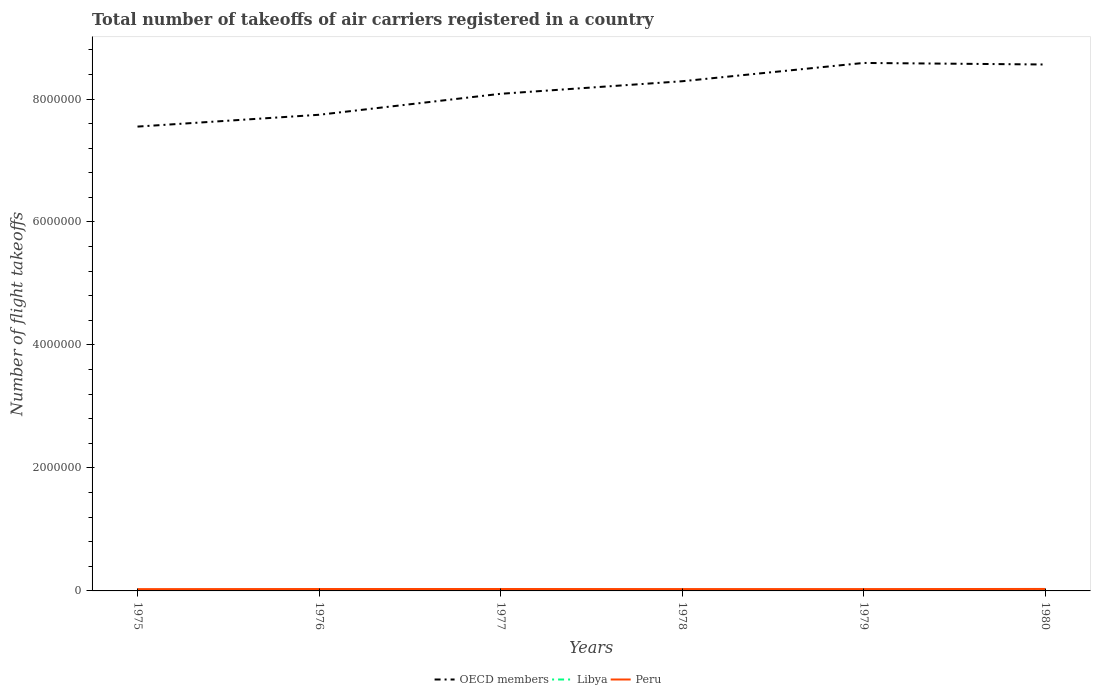How many different coloured lines are there?
Give a very brief answer. 3. Does the line corresponding to OECD members intersect with the line corresponding to Peru?
Provide a succinct answer. No. Across all years, what is the maximum total number of flight takeoffs in OECD members?
Your response must be concise. 7.55e+06. In which year was the total number of flight takeoffs in OECD members maximum?
Keep it short and to the point. 1975. What is the total total number of flight takeoffs in OECD members in the graph?
Offer a very short reply. -5.02e+05. What is the difference between the highest and the second highest total number of flight takeoffs in Libya?
Your answer should be compact. 2700. What is the difference between the highest and the lowest total number of flight takeoffs in Peru?
Make the answer very short. 3. Is the total number of flight takeoffs in OECD members strictly greater than the total number of flight takeoffs in Libya over the years?
Your answer should be very brief. No. How many lines are there?
Ensure brevity in your answer.  3. Does the graph contain any zero values?
Your answer should be very brief. No. Where does the legend appear in the graph?
Give a very brief answer. Bottom center. How many legend labels are there?
Offer a very short reply. 3. How are the legend labels stacked?
Keep it short and to the point. Horizontal. What is the title of the graph?
Keep it short and to the point. Total number of takeoffs of air carriers registered in a country. Does "Poland" appear as one of the legend labels in the graph?
Give a very brief answer. No. What is the label or title of the X-axis?
Your answer should be very brief. Years. What is the label or title of the Y-axis?
Give a very brief answer. Number of flight takeoffs. What is the Number of flight takeoffs in OECD members in 1975?
Give a very brief answer. 7.55e+06. What is the Number of flight takeoffs of Libya in 1975?
Give a very brief answer. 9500. What is the Number of flight takeoffs in Peru in 1975?
Your response must be concise. 2.93e+04. What is the Number of flight takeoffs in OECD members in 1976?
Make the answer very short. 7.74e+06. What is the Number of flight takeoffs of Libya in 1976?
Offer a very short reply. 9800. What is the Number of flight takeoffs in Peru in 1976?
Your answer should be compact. 3.09e+04. What is the Number of flight takeoffs of OECD members in 1977?
Offer a terse response. 8.08e+06. What is the Number of flight takeoffs of Libya in 1977?
Give a very brief answer. 1.11e+04. What is the Number of flight takeoffs of Peru in 1977?
Make the answer very short. 3.12e+04. What is the Number of flight takeoffs of OECD members in 1978?
Make the answer very short. 8.29e+06. What is the Number of flight takeoffs in Libya in 1978?
Give a very brief answer. 1.11e+04. What is the Number of flight takeoffs of Peru in 1978?
Keep it short and to the point. 3.03e+04. What is the Number of flight takeoffs of OECD members in 1979?
Ensure brevity in your answer.  8.59e+06. What is the Number of flight takeoffs in Libya in 1979?
Provide a succinct answer. 1.16e+04. What is the Number of flight takeoffs in Peru in 1979?
Make the answer very short. 2.99e+04. What is the Number of flight takeoffs of OECD members in 1980?
Offer a very short reply. 8.56e+06. What is the Number of flight takeoffs in Libya in 1980?
Ensure brevity in your answer.  1.22e+04. What is the Number of flight takeoffs of Peru in 1980?
Your answer should be very brief. 3.21e+04. Across all years, what is the maximum Number of flight takeoffs in OECD members?
Keep it short and to the point. 8.59e+06. Across all years, what is the maximum Number of flight takeoffs of Libya?
Provide a short and direct response. 1.22e+04. Across all years, what is the maximum Number of flight takeoffs in Peru?
Offer a terse response. 3.21e+04. Across all years, what is the minimum Number of flight takeoffs of OECD members?
Make the answer very short. 7.55e+06. Across all years, what is the minimum Number of flight takeoffs in Libya?
Give a very brief answer. 9500. Across all years, what is the minimum Number of flight takeoffs of Peru?
Offer a terse response. 2.93e+04. What is the total Number of flight takeoffs of OECD members in the graph?
Your response must be concise. 4.88e+07. What is the total Number of flight takeoffs in Libya in the graph?
Offer a terse response. 6.53e+04. What is the total Number of flight takeoffs in Peru in the graph?
Keep it short and to the point. 1.84e+05. What is the difference between the Number of flight takeoffs of OECD members in 1975 and that in 1976?
Offer a very short reply. -1.92e+05. What is the difference between the Number of flight takeoffs in Libya in 1975 and that in 1976?
Your answer should be very brief. -300. What is the difference between the Number of flight takeoffs in Peru in 1975 and that in 1976?
Provide a succinct answer. -1600. What is the difference between the Number of flight takeoffs of OECD members in 1975 and that in 1977?
Your response must be concise. -5.33e+05. What is the difference between the Number of flight takeoffs of Libya in 1975 and that in 1977?
Your response must be concise. -1600. What is the difference between the Number of flight takeoffs in Peru in 1975 and that in 1977?
Give a very brief answer. -1900. What is the difference between the Number of flight takeoffs in OECD members in 1975 and that in 1978?
Ensure brevity in your answer.  -7.38e+05. What is the difference between the Number of flight takeoffs in Libya in 1975 and that in 1978?
Your answer should be compact. -1600. What is the difference between the Number of flight takeoffs of Peru in 1975 and that in 1978?
Offer a terse response. -1000. What is the difference between the Number of flight takeoffs of OECD members in 1975 and that in 1979?
Make the answer very short. -1.04e+06. What is the difference between the Number of flight takeoffs in Libya in 1975 and that in 1979?
Ensure brevity in your answer.  -2100. What is the difference between the Number of flight takeoffs of Peru in 1975 and that in 1979?
Give a very brief answer. -600. What is the difference between the Number of flight takeoffs of OECD members in 1975 and that in 1980?
Your answer should be very brief. -1.01e+06. What is the difference between the Number of flight takeoffs of Libya in 1975 and that in 1980?
Make the answer very short. -2700. What is the difference between the Number of flight takeoffs of Peru in 1975 and that in 1980?
Provide a succinct answer. -2800. What is the difference between the Number of flight takeoffs of OECD members in 1976 and that in 1977?
Make the answer very short. -3.41e+05. What is the difference between the Number of flight takeoffs of Libya in 1976 and that in 1977?
Ensure brevity in your answer.  -1300. What is the difference between the Number of flight takeoffs in Peru in 1976 and that in 1977?
Give a very brief answer. -300. What is the difference between the Number of flight takeoffs in OECD members in 1976 and that in 1978?
Your response must be concise. -5.45e+05. What is the difference between the Number of flight takeoffs in Libya in 1976 and that in 1978?
Provide a succinct answer. -1300. What is the difference between the Number of flight takeoffs in Peru in 1976 and that in 1978?
Keep it short and to the point. 600. What is the difference between the Number of flight takeoffs in OECD members in 1976 and that in 1979?
Your answer should be compact. -8.43e+05. What is the difference between the Number of flight takeoffs of Libya in 1976 and that in 1979?
Offer a terse response. -1800. What is the difference between the Number of flight takeoffs in OECD members in 1976 and that in 1980?
Keep it short and to the point. -8.18e+05. What is the difference between the Number of flight takeoffs of Libya in 1976 and that in 1980?
Provide a short and direct response. -2400. What is the difference between the Number of flight takeoffs of Peru in 1976 and that in 1980?
Offer a very short reply. -1200. What is the difference between the Number of flight takeoffs in OECD members in 1977 and that in 1978?
Offer a very short reply. -2.04e+05. What is the difference between the Number of flight takeoffs in Libya in 1977 and that in 1978?
Give a very brief answer. 0. What is the difference between the Number of flight takeoffs of Peru in 1977 and that in 1978?
Offer a terse response. 900. What is the difference between the Number of flight takeoffs in OECD members in 1977 and that in 1979?
Offer a very short reply. -5.02e+05. What is the difference between the Number of flight takeoffs of Libya in 1977 and that in 1979?
Your answer should be compact. -500. What is the difference between the Number of flight takeoffs of Peru in 1977 and that in 1979?
Offer a very short reply. 1300. What is the difference between the Number of flight takeoffs of OECD members in 1977 and that in 1980?
Your answer should be compact. -4.77e+05. What is the difference between the Number of flight takeoffs in Libya in 1977 and that in 1980?
Your answer should be compact. -1100. What is the difference between the Number of flight takeoffs of Peru in 1977 and that in 1980?
Keep it short and to the point. -900. What is the difference between the Number of flight takeoffs of OECD members in 1978 and that in 1979?
Keep it short and to the point. -2.98e+05. What is the difference between the Number of flight takeoffs of Libya in 1978 and that in 1979?
Make the answer very short. -500. What is the difference between the Number of flight takeoffs of Peru in 1978 and that in 1979?
Your answer should be compact. 400. What is the difference between the Number of flight takeoffs in OECD members in 1978 and that in 1980?
Your answer should be compact. -2.72e+05. What is the difference between the Number of flight takeoffs of Libya in 1978 and that in 1980?
Give a very brief answer. -1100. What is the difference between the Number of flight takeoffs in Peru in 1978 and that in 1980?
Provide a short and direct response. -1800. What is the difference between the Number of flight takeoffs of OECD members in 1979 and that in 1980?
Offer a terse response. 2.53e+04. What is the difference between the Number of flight takeoffs of Libya in 1979 and that in 1980?
Give a very brief answer. -600. What is the difference between the Number of flight takeoffs in Peru in 1979 and that in 1980?
Make the answer very short. -2200. What is the difference between the Number of flight takeoffs in OECD members in 1975 and the Number of flight takeoffs in Libya in 1976?
Provide a succinct answer. 7.54e+06. What is the difference between the Number of flight takeoffs of OECD members in 1975 and the Number of flight takeoffs of Peru in 1976?
Your answer should be very brief. 7.52e+06. What is the difference between the Number of flight takeoffs of Libya in 1975 and the Number of flight takeoffs of Peru in 1976?
Your response must be concise. -2.14e+04. What is the difference between the Number of flight takeoffs in OECD members in 1975 and the Number of flight takeoffs in Libya in 1977?
Keep it short and to the point. 7.54e+06. What is the difference between the Number of flight takeoffs in OECD members in 1975 and the Number of flight takeoffs in Peru in 1977?
Ensure brevity in your answer.  7.52e+06. What is the difference between the Number of flight takeoffs in Libya in 1975 and the Number of flight takeoffs in Peru in 1977?
Your response must be concise. -2.17e+04. What is the difference between the Number of flight takeoffs of OECD members in 1975 and the Number of flight takeoffs of Libya in 1978?
Make the answer very short. 7.54e+06. What is the difference between the Number of flight takeoffs in OECD members in 1975 and the Number of flight takeoffs in Peru in 1978?
Offer a terse response. 7.52e+06. What is the difference between the Number of flight takeoffs of Libya in 1975 and the Number of flight takeoffs of Peru in 1978?
Ensure brevity in your answer.  -2.08e+04. What is the difference between the Number of flight takeoffs in OECD members in 1975 and the Number of flight takeoffs in Libya in 1979?
Keep it short and to the point. 7.54e+06. What is the difference between the Number of flight takeoffs in OECD members in 1975 and the Number of flight takeoffs in Peru in 1979?
Provide a succinct answer. 7.52e+06. What is the difference between the Number of flight takeoffs in Libya in 1975 and the Number of flight takeoffs in Peru in 1979?
Ensure brevity in your answer.  -2.04e+04. What is the difference between the Number of flight takeoffs of OECD members in 1975 and the Number of flight takeoffs of Libya in 1980?
Provide a short and direct response. 7.54e+06. What is the difference between the Number of flight takeoffs of OECD members in 1975 and the Number of flight takeoffs of Peru in 1980?
Your response must be concise. 7.52e+06. What is the difference between the Number of flight takeoffs of Libya in 1975 and the Number of flight takeoffs of Peru in 1980?
Provide a short and direct response. -2.26e+04. What is the difference between the Number of flight takeoffs in OECD members in 1976 and the Number of flight takeoffs in Libya in 1977?
Provide a succinct answer. 7.73e+06. What is the difference between the Number of flight takeoffs in OECD members in 1976 and the Number of flight takeoffs in Peru in 1977?
Ensure brevity in your answer.  7.71e+06. What is the difference between the Number of flight takeoffs of Libya in 1976 and the Number of flight takeoffs of Peru in 1977?
Offer a terse response. -2.14e+04. What is the difference between the Number of flight takeoffs in OECD members in 1976 and the Number of flight takeoffs in Libya in 1978?
Give a very brief answer. 7.73e+06. What is the difference between the Number of flight takeoffs of OECD members in 1976 and the Number of flight takeoffs of Peru in 1978?
Your answer should be very brief. 7.71e+06. What is the difference between the Number of flight takeoffs in Libya in 1976 and the Number of flight takeoffs in Peru in 1978?
Provide a short and direct response. -2.05e+04. What is the difference between the Number of flight takeoffs of OECD members in 1976 and the Number of flight takeoffs of Libya in 1979?
Offer a very short reply. 7.73e+06. What is the difference between the Number of flight takeoffs in OECD members in 1976 and the Number of flight takeoffs in Peru in 1979?
Offer a terse response. 7.71e+06. What is the difference between the Number of flight takeoffs of Libya in 1976 and the Number of flight takeoffs of Peru in 1979?
Your response must be concise. -2.01e+04. What is the difference between the Number of flight takeoffs in OECD members in 1976 and the Number of flight takeoffs in Libya in 1980?
Ensure brevity in your answer.  7.73e+06. What is the difference between the Number of flight takeoffs in OECD members in 1976 and the Number of flight takeoffs in Peru in 1980?
Give a very brief answer. 7.71e+06. What is the difference between the Number of flight takeoffs in Libya in 1976 and the Number of flight takeoffs in Peru in 1980?
Ensure brevity in your answer.  -2.23e+04. What is the difference between the Number of flight takeoffs of OECD members in 1977 and the Number of flight takeoffs of Libya in 1978?
Offer a terse response. 8.07e+06. What is the difference between the Number of flight takeoffs of OECD members in 1977 and the Number of flight takeoffs of Peru in 1978?
Make the answer very short. 8.05e+06. What is the difference between the Number of flight takeoffs in Libya in 1977 and the Number of flight takeoffs in Peru in 1978?
Ensure brevity in your answer.  -1.92e+04. What is the difference between the Number of flight takeoffs of OECD members in 1977 and the Number of flight takeoffs of Libya in 1979?
Provide a succinct answer. 8.07e+06. What is the difference between the Number of flight takeoffs of OECD members in 1977 and the Number of flight takeoffs of Peru in 1979?
Give a very brief answer. 8.05e+06. What is the difference between the Number of flight takeoffs of Libya in 1977 and the Number of flight takeoffs of Peru in 1979?
Give a very brief answer. -1.88e+04. What is the difference between the Number of flight takeoffs in OECD members in 1977 and the Number of flight takeoffs in Libya in 1980?
Your answer should be compact. 8.07e+06. What is the difference between the Number of flight takeoffs of OECD members in 1977 and the Number of flight takeoffs of Peru in 1980?
Your response must be concise. 8.05e+06. What is the difference between the Number of flight takeoffs of Libya in 1977 and the Number of flight takeoffs of Peru in 1980?
Provide a succinct answer. -2.10e+04. What is the difference between the Number of flight takeoffs of OECD members in 1978 and the Number of flight takeoffs of Libya in 1979?
Provide a succinct answer. 8.28e+06. What is the difference between the Number of flight takeoffs in OECD members in 1978 and the Number of flight takeoffs in Peru in 1979?
Ensure brevity in your answer.  8.26e+06. What is the difference between the Number of flight takeoffs of Libya in 1978 and the Number of flight takeoffs of Peru in 1979?
Give a very brief answer. -1.88e+04. What is the difference between the Number of flight takeoffs in OECD members in 1978 and the Number of flight takeoffs in Libya in 1980?
Offer a very short reply. 8.28e+06. What is the difference between the Number of flight takeoffs in OECD members in 1978 and the Number of flight takeoffs in Peru in 1980?
Your answer should be very brief. 8.26e+06. What is the difference between the Number of flight takeoffs in Libya in 1978 and the Number of flight takeoffs in Peru in 1980?
Your response must be concise. -2.10e+04. What is the difference between the Number of flight takeoffs of OECD members in 1979 and the Number of flight takeoffs of Libya in 1980?
Make the answer very short. 8.57e+06. What is the difference between the Number of flight takeoffs of OECD members in 1979 and the Number of flight takeoffs of Peru in 1980?
Give a very brief answer. 8.55e+06. What is the difference between the Number of flight takeoffs of Libya in 1979 and the Number of flight takeoffs of Peru in 1980?
Offer a very short reply. -2.05e+04. What is the average Number of flight takeoffs of OECD members per year?
Your answer should be compact. 8.14e+06. What is the average Number of flight takeoffs of Libya per year?
Keep it short and to the point. 1.09e+04. What is the average Number of flight takeoffs in Peru per year?
Your answer should be very brief. 3.06e+04. In the year 1975, what is the difference between the Number of flight takeoffs of OECD members and Number of flight takeoffs of Libya?
Your response must be concise. 7.54e+06. In the year 1975, what is the difference between the Number of flight takeoffs of OECD members and Number of flight takeoffs of Peru?
Your response must be concise. 7.52e+06. In the year 1975, what is the difference between the Number of flight takeoffs in Libya and Number of flight takeoffs in Peru?
Ensure brevity in your answer.  -1.98e+04. In the year 1976, what is the difference between the Number of flight takeoffs of OECD members and Number of flight takeoffs of Libya?
Keep it short and to the point. 7.73e+06. In the year 1976, what is the difference between the Number of flight takeoffs of OECD members and Number of flight takeoffs of Peru?
Ensure brevity in your answer.  7.71e+06. In the year 1976, what is the difference between the Number of flight takeoffs of Libya and Number of flight takeoffs of Peru?
Offer a very short reply. -2.11e+04. In the year 1977, what is the difference between the Number of flight takeoffs in OECD members and Number of flight takeoffs in Libya?
Provide a succinct answer. 8.07e+06. In the year 1977, what is the difference between the Number of flight takeoffs in OECD members and Number of flight takeoffs in Peru?
Your response must be concise. 8.05e+06. In the year 1977, what is the difference between the Number of flight takeoffs of Libya and Number of flight takeoffs of Peru?
Provide a short and direct response. -2.01e+04. In the year 1978, what is the difference between the Number of flight takeoffs of OECD members and Number of flight takeoffs of Libya?
Provide a succinct answer. 8.28e+06. In the year 1978, what is the difference between the Number of flight takeoffs of OECD members and Number of flight takeoffs of Peru?
Give a very brief answer. 8.26e+06. In the year 1978, what is the difference between the Number of flight takeoffs of Libya and Number of flight takeoffs of Peru?
Keep it short and to the point. -1.92e+04. In the year 1979, what is the difference between the Number of flight takeoffs in OECD members and Number of flight takeoffs in Libya?
Your answer should be compact. 8.58e+06. In the year 1979, what is the difference between the Number of flight takeoffs in OECD members and Number of flight takeoffs in Peru?
Offer a terse response. 8.56e+06. In the year 1979, what is the difference between the Number of flight takeoffs of Libya and Number of flight takeoffs of Peru?
Provide a succinct answer. -1.83e+04. In the year 1980, what is the difference between the Number of flight takeoffs of OECD members and Number of flight takeoffs of Libya?
Make the answer very short. 8.55e+06. In the year 1980, what is the difference between the Number of flight takeoffs of OECD members and Number of flight takeoffs of Peru?
Your answer should be very brief. 8.53e+06. In the year 1980, what is the difference between the Number of flight takeoffs in Libya and Number of flight takeoffs in Peru?
Offer a terse response. -1.99e+04. What is the ratio of the Number of flight takeoffs of OECD members in 1975 to that in 1976?
Keep it short and to the point. 0.98. What is the ratio of the Number of flight takeoffs in Libya in 1975 to that in 1976?
Keep it short and to the point. 0.97. What is the ratio of the Number of flight takeoffs of Peru in 1975 to that in 1976?
Your answer should be very brief. 0.95. What is the ratio of the Number of flight takeoffs of OECD members in 1975 to that in 1977?
Provide a short and direct response. 0.93. What is the ratio of the Number of flight takeoffs of Libya in 1975 to that in 1977?
Offer a very short reply. 0.86. What is the ratio of the Number of flight takeoffs in Peru in 1975 to that in 1977?
Make the answer very short. 0.94. What is the ratio of the Number of flight takeoffs of OECD members in 1975 to that in 1978?
Your answer should be compact. 0.91. What is the ratio of the Number of flight takeoffs in Libya in 1975 to that in 1978?
Offer a very short reply. 0.86. What is the ratio of the Number of flight takeoffs in OECD members in 1975 to that in 1979?
Offer a very short reply. 0.88. What is the ratio of the Number of flight takeoffs in Libya in 1975 to that in 1979?
Your response must be concise. 0.82. What is the ratio of the Number of flight takeoffs of Peru in 1975 to that in 1979?
Keep it short and to the point. 0.98. What is the ratio of the Number of flight takeoffs of OECD members in 1975 to that in 1980?
Ensure brevity in your answer.  0.88. What is the ratio of the Number of flight takeoffs of Libya in 1975 to that in 1980?
Your answer should be very brief. 0.78. What is the ratio of the Number of flight takeoffs in Peru in 1975 to that in 1980?
Make the answer very short. 0.91. What is the ratio of the Number of flight takeoffs in OECD members in 1976 to that in 1977?
Your response must be concise. 0.96. What is the ratio of the Number of flight takeoffs in Libya in 1976 to that in 1977?
Your answer should be very brief. 0.88. What is the ratio of the Number of flight takeoffs in OECD members in 1976 to that in 1978?
Make the answer very short. 0.93. What is the ratio of the Number of flight takeoffs in Libya in 1976 to that in 1978?
Your response must be concise. 0.88. What is the ratio of the Number of flight takeoffs of Peru in 1976 to that in 1978?
Your answer should be compact. 1.02. What is the ratio of the Number of flight takeoffs of OECD members in 1976 to that in 1979?
Provide a succinct answer. 0.9. What is the ratio of the Number of flight takeoffs of Libya in 1976 to that in 1979?
Offer a terse response. 0.84. What is the ratio of the Number of flight takeoffs of Peru in 1976 to that in 1979?
Make the answer very short. 1.03. What is the ratio of the Number of flight takeoffs of OECD members in 1976 to that in 1980?
Keep it short and to the point. 0.9. What is the ratio of the Number of flight takeoffs of Libya in 1976 to that in 1980?
Provide a succinct answer. 0.8. What is the ratio of the Number of flight takeoffs in Peru in 1976 to that in 1980?
Offer a terse response. 0.96. What is the ratio of the Number of flight takeoffs in OECD members in 1977 to that in 1978?
Your answer should be very brief. 0.98. What is the ratio of the Number of flight takeoffs in Peru in 1977 to that in 1978?
Your answer should be very brief. 1.03. What is the ratio of the Number of flight takeoffs of OECD members in 1977 to that in 1979?
Make the answer very short. 0.94. What is the ratio of the Number of flight takeoffs of Libya in 1977 to that in 1979?
Offer a very short reply. 0.96. What is the ratio of the Number of flight takeoffs of Peru in 1977 to that in 1979?
Provide a succinct answer. 1.04. What is the ratio of the Number of flight takeoffs in OECD members in 1977 to that in 1980?
Offer a very short reply. 0.94. What is the ratio of the Number of flight takeoffs in Libya in 1977 to that in 1980?
Make the answer very short. 0.91. What is the ratio of the Number of flight takeoffs in Peru in 1977 to that in 1980?
Give a very brief answer. 0.97. What is the ratio of the Number of flight takeoffs in OECD members in 1978 to that in 1979?
Give a very brief answer. 0.97. What is the ratio of the Number of flight takeoffs of Libya in 1978 to that in 1979?
Your response must be concise. 0.96. What is the ratio of the Number of flight takeoffs of Peru in 1978 to that in 1979?
Your answer should be compact. 1.01. What is the ratio of the Number of flight takeoffs in OECD members in 1978 to that in 1980?
Provide a succinct answer. 0.97. What is the ratio of the Number of flight takeoffs of Libya in 1978 to that in 1980?
Provide a short and direct response. 0.91. What is the ratio of the Number of flight takeoffs of Peru in 1978 to that in 1980?
Your answer should be very brief. 0.94. What is the ratio of the Number of flight takeoffs in Libya in 1979 to that in 1980?
Ensure brevity in your answer.  0.95. What is the ratio of the Number of flight takeoffs of Peru in 1979 to that in 1980?
Your answer should be compact. 0.93. What is the difference between the highest and the second highest Number of flight takeoffs of OECD members?
Offer a very short reply. 2.53e+04. What is the difference between the highest and the second highest Number of flight takeoffs in Libya?
Your answer should be very brief. 600. What is the difference between the highest and the second highest Number of flight takeoffs of Peru?
Make the answer very short. 900. What is the difference between the highest and the lowest Number of flight takeoffs in OECD members?
Provide a short and direct response. 1.04e+06. What is the difference between the highest and the lowest Number of flight takeoffs of Libya?
Keep it short and to the point. 2700. What is the difference between the highest and the lowest Number of flight takeoffs in Peru?
Provide a short and direct response. 2800. 